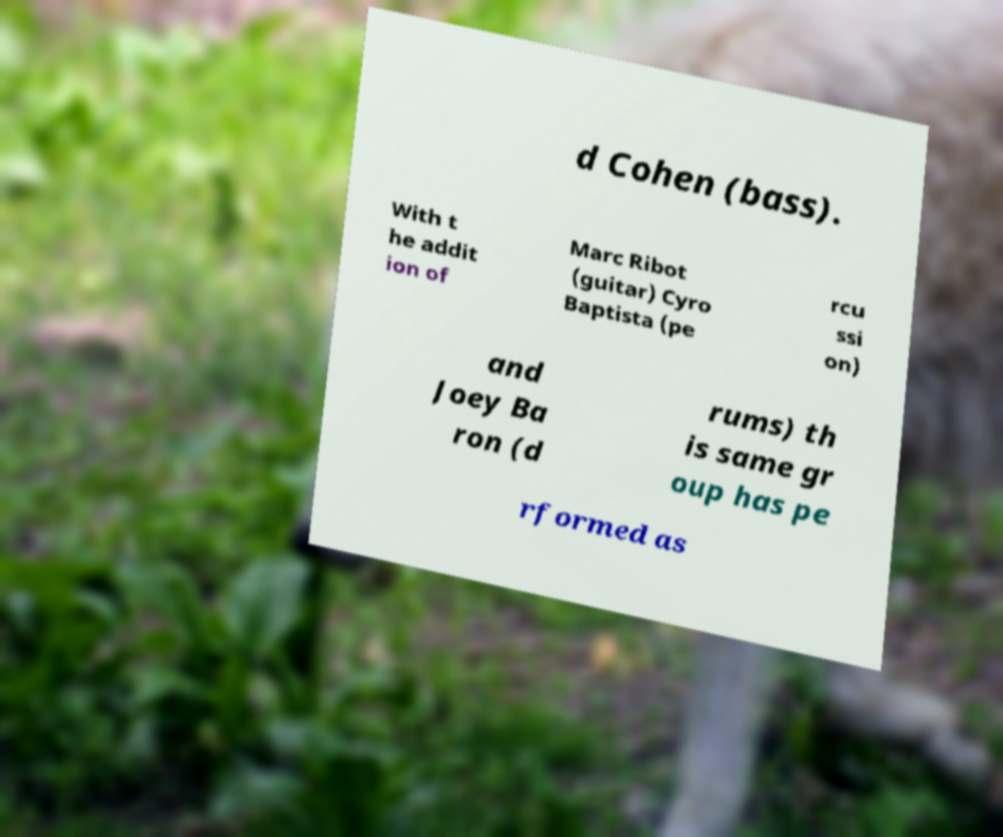For documentation purposes, I need the text within this image transcribed. Could you provide that? d Cohen (bass). With t he addit ion of Marc Ribot (guitar) Cyro Baptista (pe rcu ssi on) and Joey Ba ron (d rums) th is same gr oup has pe rformed as 